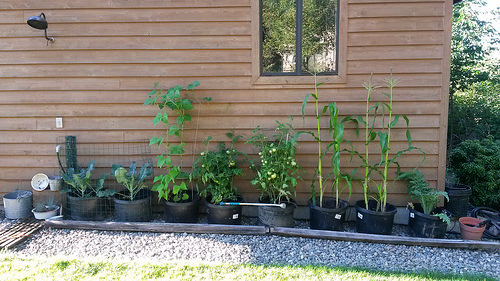<image>
Is there a window above the plant? Yes. The window is positioned above the plant in the vertical space, higher up in the scene. 